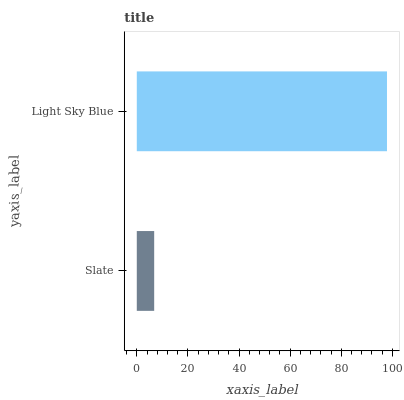Is Slate the minimum?
Answer yes or no. Yes. Is Light Sky Blue the maximum?
Answer yes or no. Yes. Is Light Sky Blue the minimum?
Answer yes or no. No. Is Light Sky Blue greater than Slate?
Answer yes or no. Yes. Is Slate less than Light Sky Blue?
Answer yes or no. Yes. Is Slate greater than Light Sky Blue?
Answer yes or no. No. Is Light Sky Blue less than Slate?
Answer yes or no. No. Is Light Sky Blue the high median?
Answer yes or no. Yes. Is Slate the low median?
Answer yes or no. Yes. Is Slate the high median?
Answer yes or no. No. Is Light Sky Blue the low median?
Answer yes or no. No. 